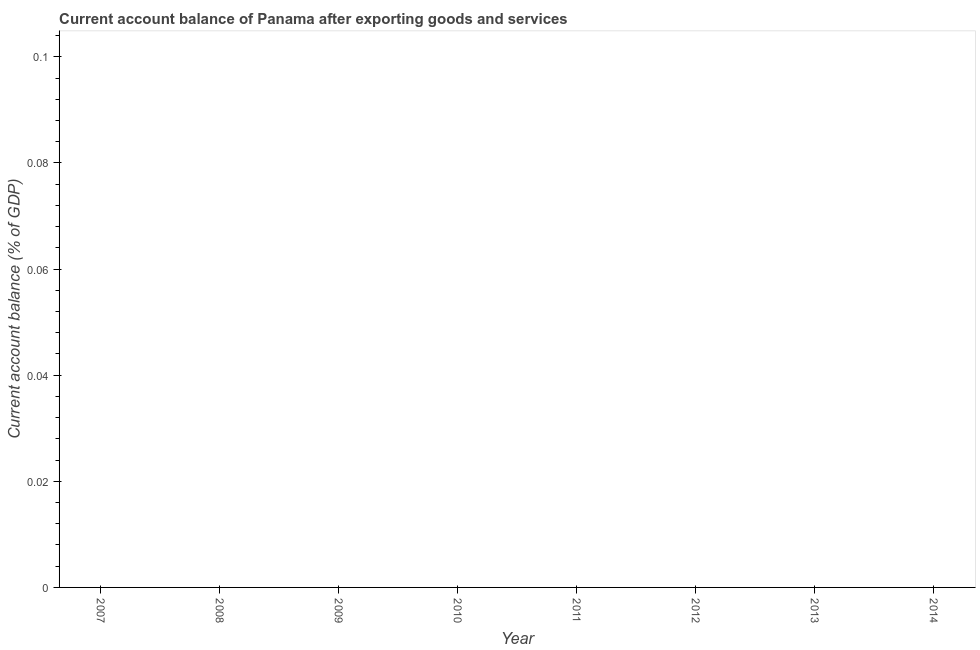What is the current account balance in 2010?
Provide a short and direct response. 0. Across all years, what is the minimum current account balance?
Make the answer very short. 0. What is the average current account balance per year?
Your response must be concise. 0. What is the median current account balance?
Keep it short and to the point. 0. In how many years, is the current account balance greater than 0.024 %?
Keep it short and to the point. 0. In how many years, is the current account balance greater than the average current account balance taken over all years?
Your answer should be very brief. 0. What is the difference between two consecutive major ticks on the Y-axis?
Your answer should be compact. 0.02. Are the values on the major ticks of Y-axis written in scientific E-notation?
Provide a short and direct response. No. Does the graph contain any zero values?
Keep it short and to the point. Yes. What is the title of the graph?
Offer a terse response. Current account balance of Panama after exporting goods and services. What is the label or title of the X-axis?
Offer a very short reply. Year. What is the label or title of the Y-axis?
Provide a succinct answer. Current account balance (% of GDP). What is the Current account balance (% of GDP) in 2007?
Make the answer very short. 0. What is the Current account balance (% of GDP) in 2009?
Offer a very short reply. 0. What is the Current account balance (% of GDP) in 2010?
Give a very brief answer. 0. What is the Current account balance (% of GDP) of 2013?
Offer a very short reply. 0. 